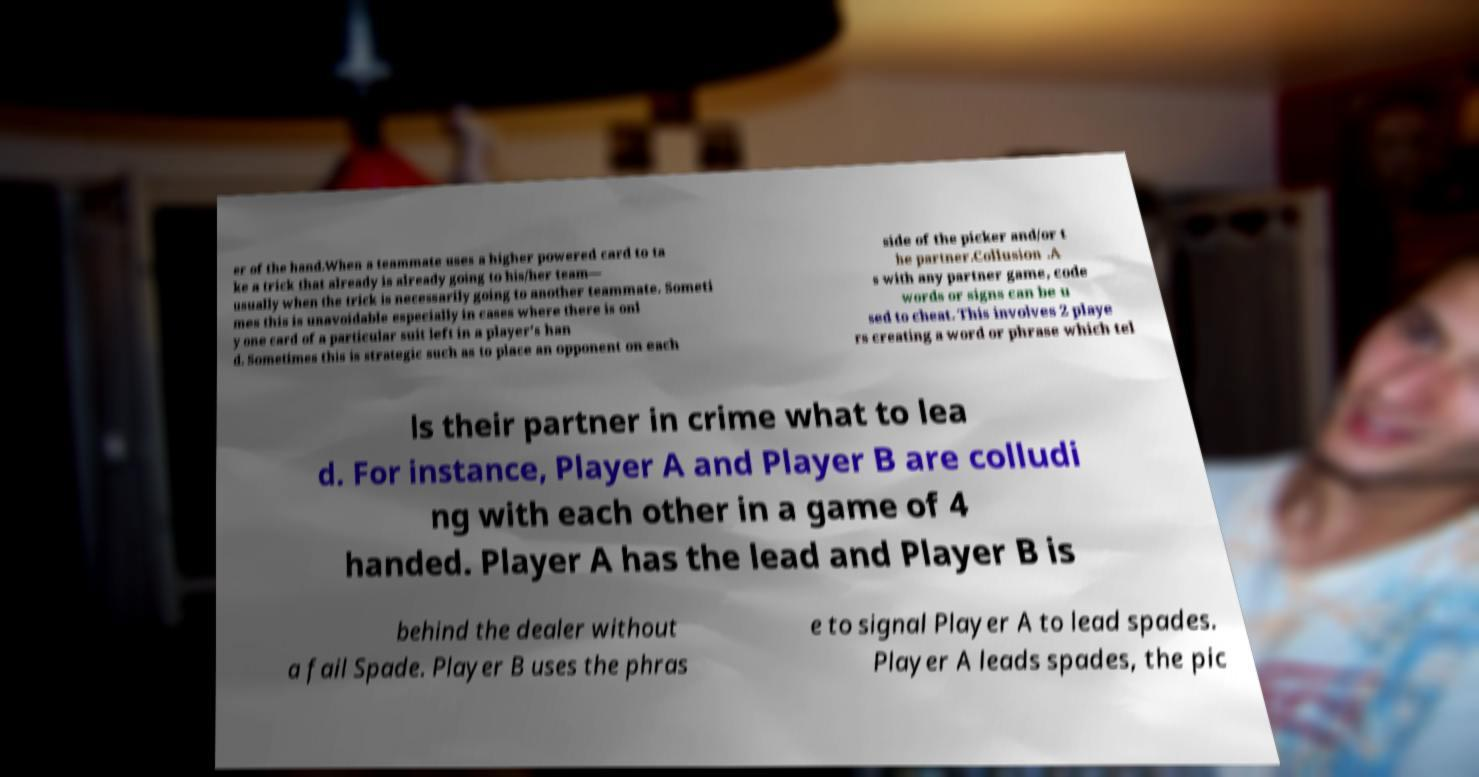I need the written content from this picture converted into text. Can you do that? er of the hand.When a teammate uses a higher powered card to ta ke a trick that already is already going to his/her team— usually when the trick is necessarily going to another teammate. Someti mes this is unavoidable especially in cases where there is onl y one card of a particular suit left in a player's han d. Sometimes this is strategic such as to place an opponent on each side of the picker and/or t he partner.Collusion .A s with any partner game, code words or signs can be u sed to cheat. This involves 2 playe rs creating a word or phrase which tel ls their partner in crime what to lea d. For instance, Player A and Player B are colludi ng with each other in a game of 4 handed. Player A has the lead and Player B is behind the dealer without a fail Spade. Player B uses the phras e to signal Player A to lead spades. Player A leads spades, the pic 